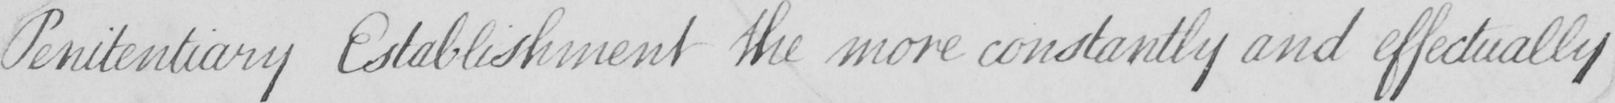Can you read and transcribe this handwriting? Penitentiary Establishment the more constantly and effectually 